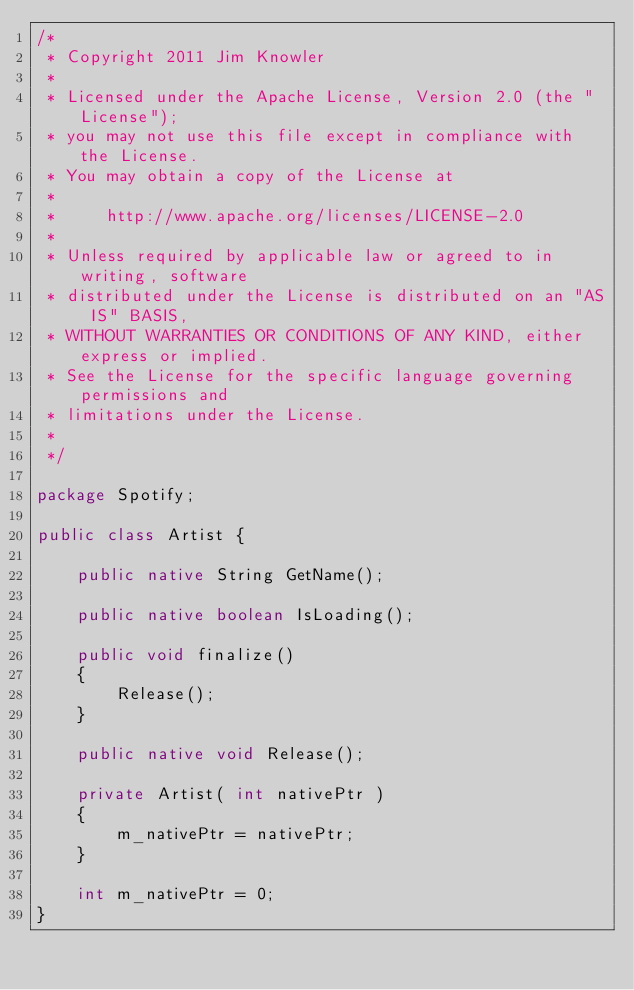<code> <loc_0><loc_0><loc_500><loc_500><_Java_>/*
 * Copyright 2011 Jim Knowler
 *
 * Licensed under the Apache License, Version 2.0 (the "License");
 * you may not use this file except in compliance with the License.
 * You may obtain a copy of the License at
 * 
 *     http://www.apache.org/licenses/LICENSE-2.0
 * 
 * Unless required by applicable law or agreed to in writing, software
 * distributed under the License is distributed on an "AS IS" BASIS,
 * WITHOUT WARRANTIES OR CONDITIONS OF ANY KIND, either express or implied.
 * See the License for the specific language governing permissions and
 * limitations under the License.
 * 
 */

package Spotify;

public class Artist {

	public native String GetName();
	
	public native boolean IsLoading();
	
	public void finalize()
	{
		Release();
	}
	
	public native void Release();	
	
	private Artist( int nativePtr )
	{
		m_nativePtr = nativePtr;
	}
	
	int m_nativePtr = 0;	
}
</code> 